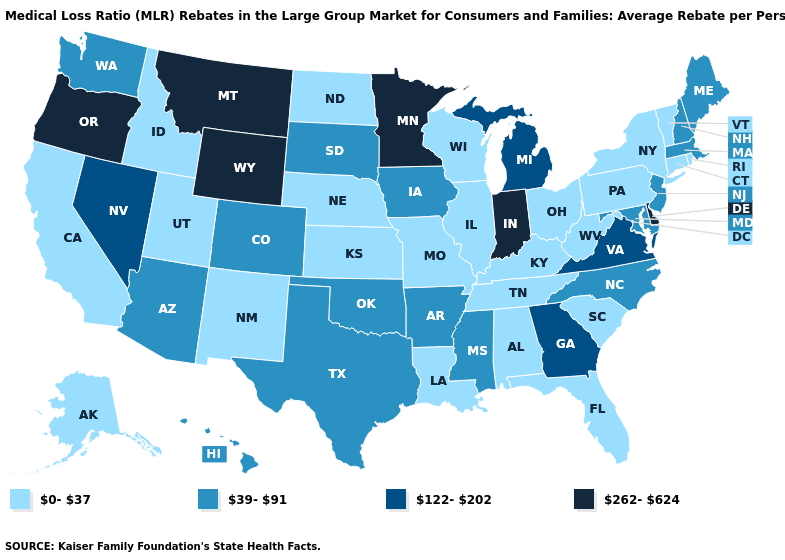What is the value of Mississippi?
Quick response, please. 39-91. Does Kentucky have the lowest value in the South?
Give a very brief answer. Yes. What is the value of Vermont?
Be succinct. 0-37. What is the lowest value in the West?
Short answer required. 0-37. Which states have the highest value in the USA?
Keep it brief. Delaware, Indiana, Minnesota, Montana, Oregon, Wyoming. Does Connecticut have the highest value in the USA?
Write a very short answer. No. Name the states that have a value in the range 122-202?
Keep it brief. Georgia, Michigan, Nevada, Virginia. What is the highest value in the USA?
Quick response, please. 262-624. Does Alaska have the lowest value in the West?
Be succinct. Yes. Which states have the highest value in the USA?
Quick response, please. Delaware, Indiana, Minnesota, Montana, Oregon, Wyoming. Name the states that have a value in the range 262-624?
Concise answer only. Delaware, Indiana, Minnesota, Montana, Oregon, Wyoming. Does the first symbol in the legend represent the smallest category?
Write a very short answer. Yes. What is the value of California?
Short answer required. 0-37. Which states hav the highest value in the West?
Quick response, please. Montana, Oregon, Wyoming. Name the states that have a value in the range 122-202?
Be succinct. Georgia, Michigan, Nevada, Virginia. 